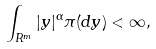Convert formula to latex. <formula><loc_0><loc_0><loc_500><loc_500>\int _ { R ^ { m } } | y | ^ { \alpha } \pi ( d y ) < \infty ,</formula> 